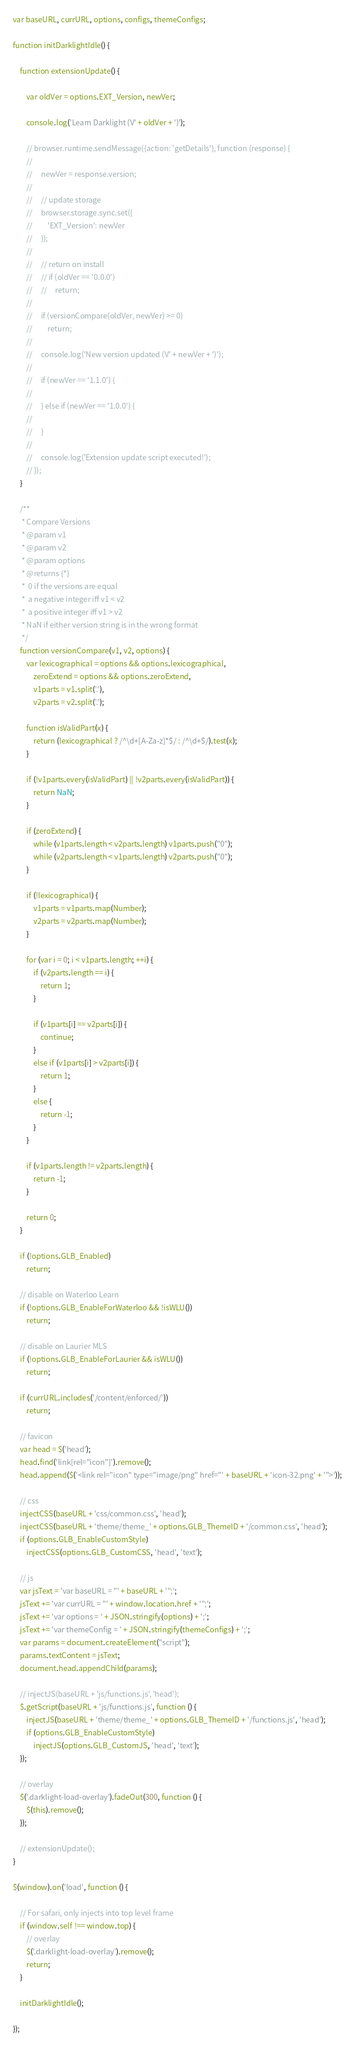Convert code to text. <code><loc_0><loc_0><loc_500><loc_500><_JavaScript_>var baseURL, currURL, options, configs, themeConfigs;

function initDarklightIdle() {

    function extensionUpdate() {

        var oldVer = options.EXT_Version, newVer;

        console.log('Learn Darklight (V' + oldVer + ')');

        // browser.runtime.sendMessage({action: 'getDetails'}, function (response) {
        //
        //     newVer = response.version;
        //
        //     // update storage
        //     browser.storage.sync.set({
        //         'EXT_Version': newVer
        //     });
        //
        //     // return on install
        //     // if (oldVer == '0.0.0')
        //     //     return;
        //
        //     if (versionCompare(oldVer, newVer) >= 0)
        //         return;
        //
        //     console.log('New version updated (V' + newVer + ')');
        //
        //     if (newVer == '1.1.0') {
        //
        //     } else if (newVer == '1.0.0') {
        //
        //     }
        //
        //     console.log('Extension update script executed!');
        // });
    }

    /**
     * Compare Versions
     * @param v1
     * @param v2
     * @param options
     * @returns {*}
     *  0 if the versions are equal
     *  a negative integer iff v1 < v2
     *  a positive integer iff v1 > v2
     * NaN if either version string is in the wrong format
     */
    function versionCompare(v1, v2, options) {
        var lexicographical = options && options.lexicographical,
            zeroExtend = options && options.zeroExtend,
            v1parts = v1.split('.'),
            v2parts = v2.split('.');

        function isValidPart(x) {
            return (lexicographical ? /^\d+[A-Za-z]*$/ : /^\d+$/).test(x);
        }

        if (!v1parts.every(isValidPart) || !v2parts.every(isValidPart)) {
            return NaN;
        }

        if (zeroExtend) {
            while (v1parts.length < v2parts.length) v1parts.push("0");
            while (v2parts.length < v1parts.length) v2parts.push("0");
        }

        if (!lexicographical) {
            v1parts = v1parts.map(Number);
            v2parts = v2parts.map(Number);
        }

        for (var i = 0; i < v1parts.length; ++i) {
            if (v2parts.length == i) {
                return 1;
            }

            if (v1parts[i] == v2parts[i]) {
                continue;
            }
            else if (v1parts[i] > v2parts[i]) {
                return 1;
            }
            else {
                return -1;
            }
        }

        if (v1parts.length != v2parts.length) {
            return -1;
        }

        return 0;
    }

    if (!options.GLB_Enabled)
        return;

    // disable on Waterloo Learn
    if (!options.GLB_EnableForWaterloo && !isWLU())
        return;

    // disable on Laurier MLS
    if (!options.GLB_EnableForLaurier && isWLU())
        return;

    if (currURL.includes('/content/enforced/'))
        return;

    // favicon
    var head = $('head');
    head.find('link[rel="icon"]').remove();
    head.append($('<link rel="icon" type="image/png" href="' + baseURL + 'icon-32.png' + '">'));

    // css
    injectCSS(baseURL + 'css/common.css', 'head');
    injectCSS(baseURL + 'theme/theme_' + options.GLB_ThemeID + '/common.css', 'head');
    if (options.GLB_EnableCustomStyle)
        injectCSS(options.GLB_CustomCSS, 'head', 'text');

    // js
    var jsText = 'var baseURL = "' + baseURL + '";';
    jsText += 'var currURL = "' + window.location.href + '";';
    jsText += 'var options = ' + JSON.stringify(options) + ';';
    jsText += 'var themeConfig = ' + JSON.stringify(themeConfigs) + ';';
    var params = document.createElement("script");
    params.textContent = jsText;
    document.head.appendChild(params);

    // injectJS(baseURL + 'js/functions.js', 'head');
    $.getScript(baseURL + 'js/functions.js', function () {
        injectJS(baseURL + 'theme/theme_' + options.GLB_ThemeID + '/functions.js', 'head');
        if (options.GLB_EnableCustomStyle)
            injectJS(options.GLB_CustomJS, 'head', 'text');
    });

    // overlay
    $('.darklight-load-overlay').fadeOut(300, function () {
        $(this).remove();
    });

    // extensionUpdate();
}

$(window).on('load', function () {

    // For safari, only injects into top level frame
    if (window.self !== window.top) {
        // overlay
        $('.darklight-load-overlay').remove();
        return;
    }

    initDarklightIdle();

});</code> 